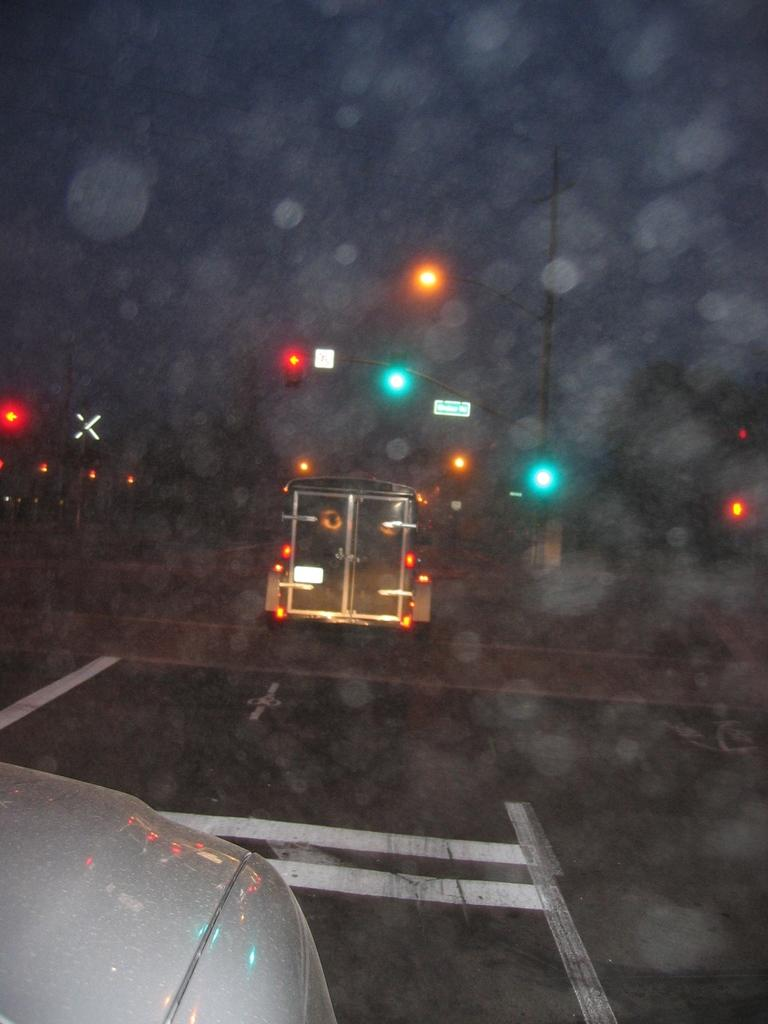What type of vehicle is located in the left corner of the image? There is a white vehicle in the left corner of the image. Can you describe the other vehicle in the image? There is another vehicle in the image, but its color or type is not specified. What is present in front of the vehicles? There are traffic lights in front of the vehicles. What type of chalk is being used to draw on the road in the image? There is no chalk or drawing on the road present in the image. 